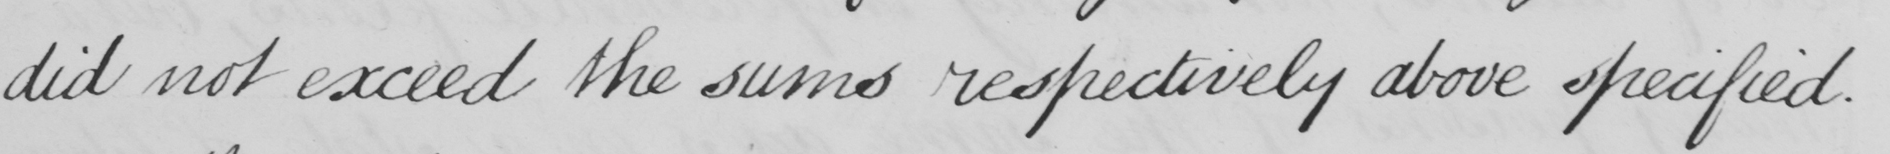Transcribe the text shown in this historical manuscript line. did not exceed the sums respectively above specified . 